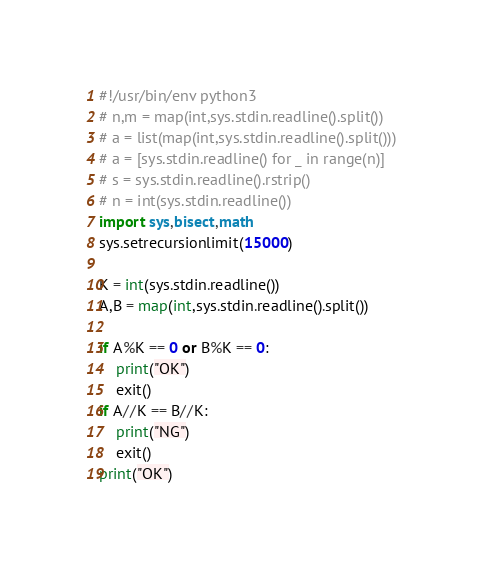Convert code to text. <code><loc_0><loc_0><loc_500><loc_500><_Python_>#!/usr/bin/env python3
# n,m = map(int,sys.stdin.readline().split())
# a = list(map(int,sys.stdin.readline().split()))
# a = [sys.stdin.readline() for _ in range(n)]
# s = sys.stdin.readline().rstrip()
# n = int(sys.stdin.readline())
import sys,bisect,math
sys.setrecursionlimit(15000)

K = int(sys.stdin.readline())
A,B = map(int,sys.stdin.readline().split())

if A%K == 0 or B%K == 0:
    print("OK")
    exit()
if A//K == B//K:
    print("NG")
    exit()
print("OK")
</code> 